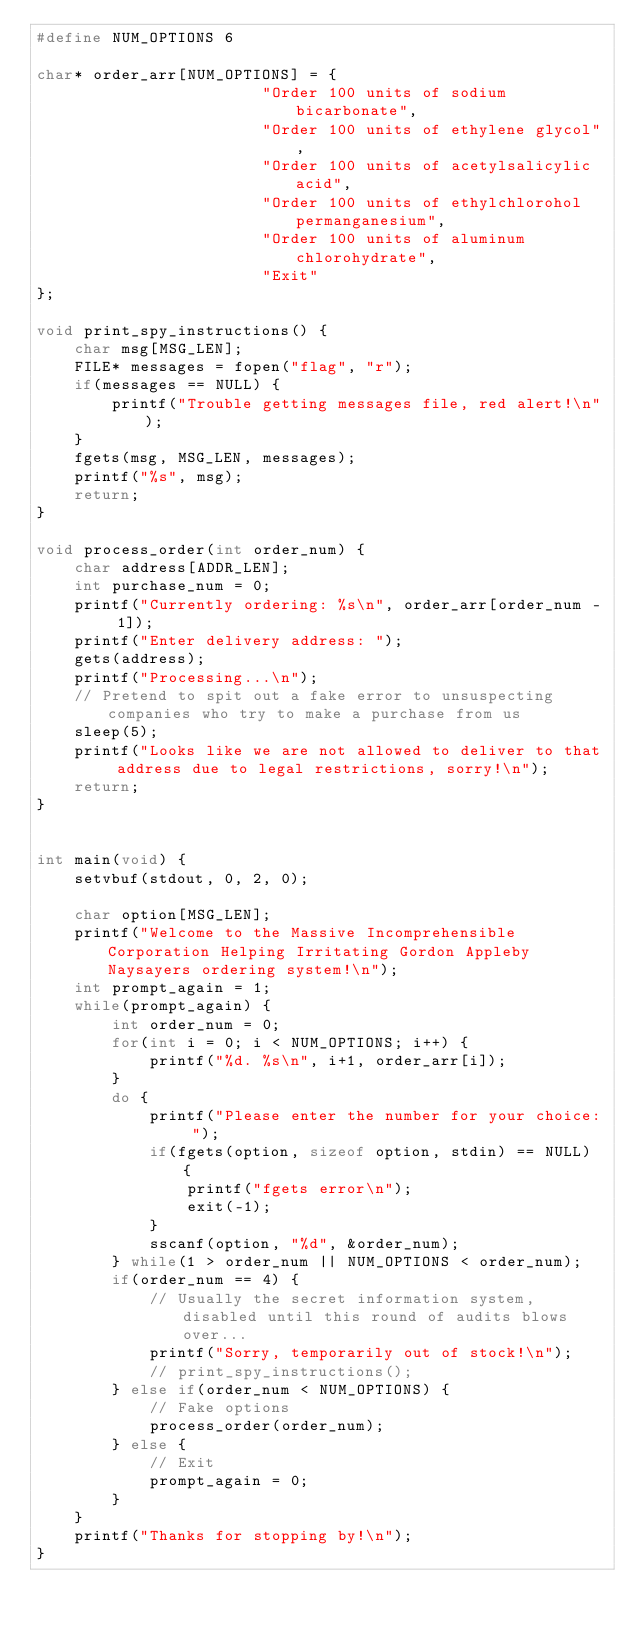Convert code to text. <code><loc_0><loc_0><loc_500><loc_500><_C_>#define NUM_OPTIONS 6

char* order_arr[NUM_OPTIONS] = {
                        "Order 100 units of sodium bicarbonate",
                        "Order 100 units of ethylene glycol",
                        "Order 100 units of acetylsalicylic acid",
                        "Order 100 units of ethylchlorohol permanganesium",
                        "Order 100 units of aluminum chlorohydrate",
                        "Exit"
};

void print_spy_instructions() {
    char msg[MSG_LEN];
    FILE* messages = fopen("flag", "r");
    if(messages == NULL) {
        printf("Trouble getting messages file, red alert!\n");
    }
    fgets(msg, MSG_LEN, messages);
    printf("%s", msg);
    return;
}

void process_order(int order_num) {
    char address[ADDR_LEN];
    int purchase_num = 0;
    printf("Currently ordering: %s\n", order_arr[order_num - 1]);
    printf("Enter delivery address: ");
    gets(address);
    printf("Processing...\n");
    // Pretend to spit out a fake error to unsuspecting companies who try to make a purchase from us
    sleep(5);
    printf("Looks like we are not allowed to deliver to that address due to legal restrictions, sorry!\n");
    return;
}


int main(void) {
    setvbuf(stdout, 0, 2, 0);

    char option[MSG_LEN];
    printf("Welcome to the Massive Incomprehensible Corporation Helping Irritating Gordon Appleby Naysayers ordering system!\n");
    int prompt_again = 1;
    while(prompt_again) {
        int order_num = 0;
        for(int i = 0; i < NUM_OPTIONS; i++) {
            printf("%d. %s\n", i+1, order_arr[i]);
        }
        do {
            printf("Please enter the number for your choice: ");
            if(fgets(option, sizeof option, stdin) == NULL) {
                printf("fgets error\n");
                exit(-1);
            }
            sscanf(option, "%d", &order_num);
        } while(1 > order_num || NUM_OPTIONS < order_num);
        if(order_num == 4) {
            // Usually the secret information system, disabled until this round of audits blows over...
            printf("Sorry, temporarily out of stock!\n");
            // print_spy_instructions();
        } else if(order_num < NUM_OPTIONS) {
            // Fake options
            process_order(order_num);
        } else {
            // Exit
            prompt_again = 0;
        }
    }
    printf("Thanks for stopping by!\n");
}
</code> 